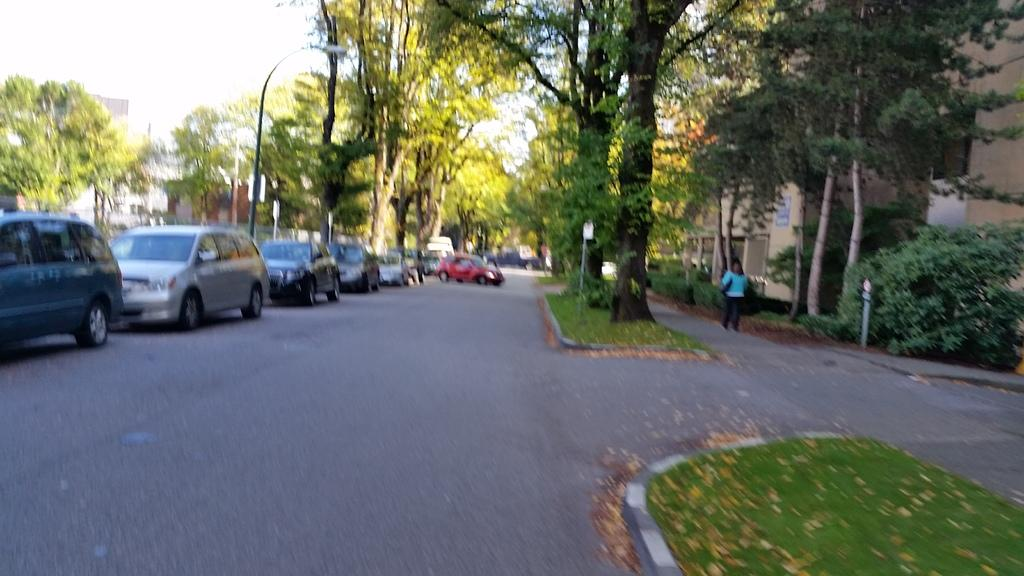What can be seen on the left side of the image? There are cars parked on the road on the left side of the image. What is located in the middle of the image? There are trees in the middle of the image. What is happening on the right side of the image? A woman is walking on the road on the right side of the image. What type of structures are visible on the right side of the image? There are buildings in the right side of the image. What type of chalk is the woman using to draw on the road? There is no chalk present in the image, and the woman is not drawing on the road. What is the woman showing to the people in the image? The image does not show the woman interacting with anyone or showing anything to them. 